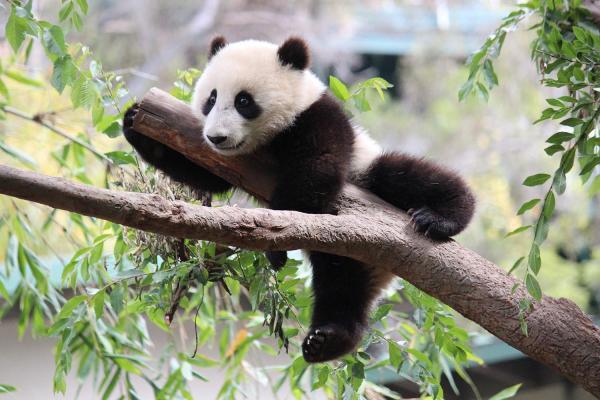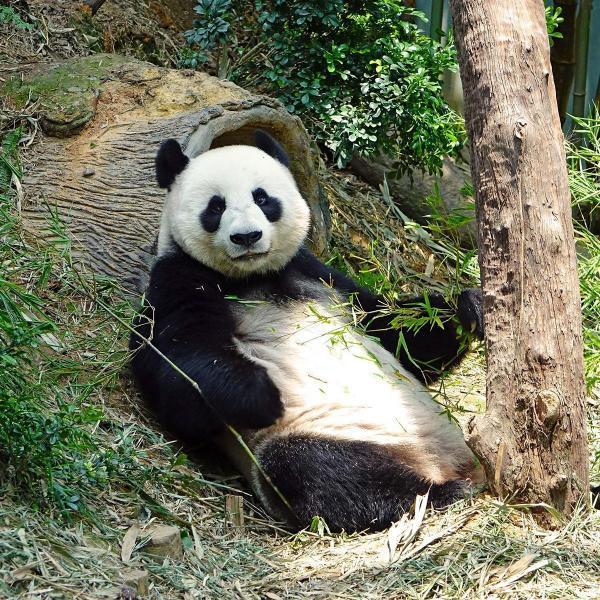The first image is the image on the left, the second image is the image on the right. Evaluate the accuracy of this statement regarding the images: "All pandas are grasping part of a bamboo plant, and at least one of the pandas depicted faces forward with his rightward elbow bent and paw raised to his mouth.". Is it true? Answer yes or no. No. The first image is the image on the left, the second image is the image on the right. For the images shown, is this caption "there is a panda sitting on the ground in front of a fallen tree log with a standing tree trunk to the right of the panda" true? Answer yes or no. Yes. 